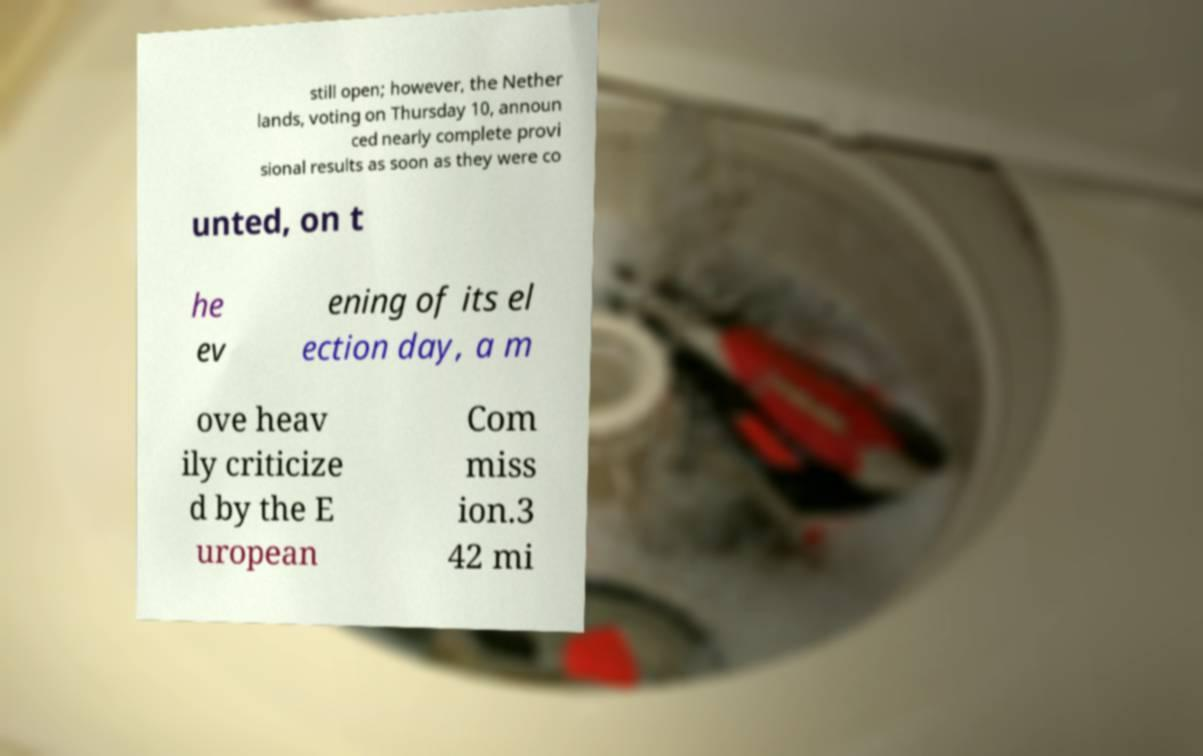There's text embedded in this image that I need extracted. Can you transcribe it verbatim? still open; however, the Nether lands, voting on Thursday 10, announ ced nearly complete provi sional results as soon as they were co unted, on t he ev ening of its el ection day, a m ove heav ily criticize d by the E uropean Com miss ion.3 42 mi 